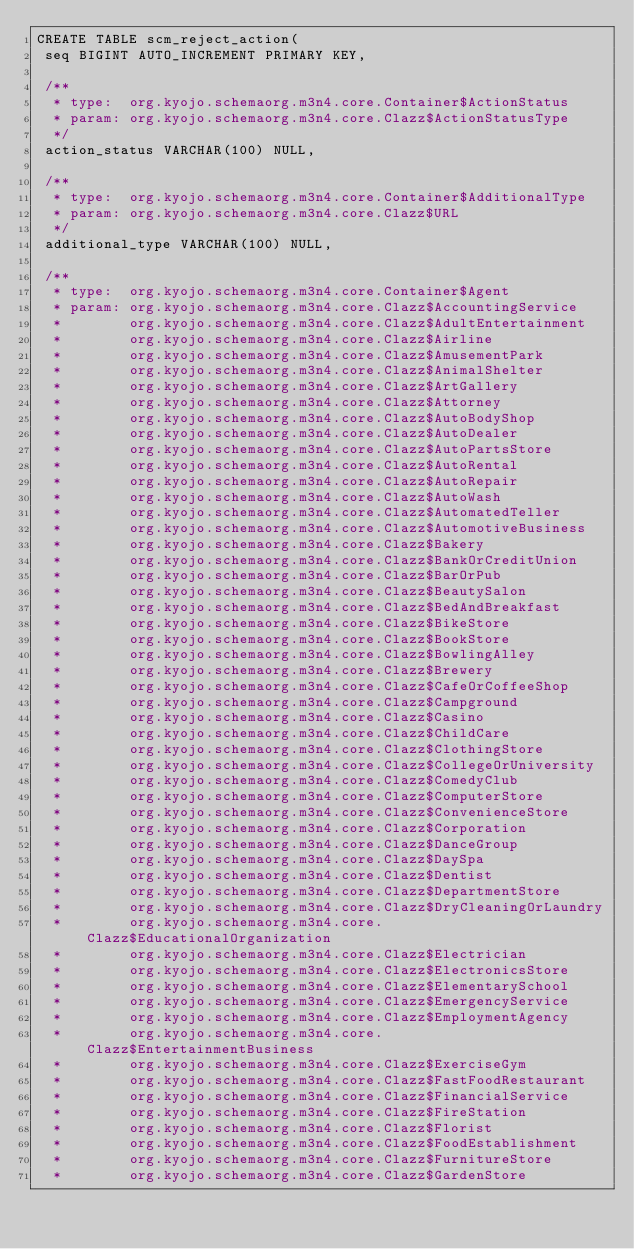Convert code to text. <code><loc_0><loc_0><loc_500><loc_500><_SQL_>CREATE TABLE scm_reject_action(
 seq BIGINT AUTO_INCREMENT PRIMARY KEY,

 /**
  * type:  org.kyojo.schemaorg.m3n4.core.Container$ActionStatus
  * param: org.kyojo.schemaorg.m3n4.core.Clazz$ActionStatusType
  */
 action_status VARCHAR(100) NULL,

 /**
  * type:  org.kyojo.schemaorg.m3n4.core.Container$AdditionalType
  * param: org.kyojo.schemaorg.m3n4.core.Clazz$URL
  */
 additional_type VARCHAR(100) NULL,

 /**
  * type:  org.kyojo.schemaorg.m3n4.core.Container$Agent
  * param: org.kyojo.schemaorg.m3n4.core.Clazz$AccountingService
  *        org.kyojo.schemaorg.m3n4.core.Clazz$AdultEntertainment
  *        org.kyojo.schemaorg.m3n4.core.Clazz$Airline
  *        org.kyojo.schemaorg.m3n4.core.Clazz$AmusementPark
  *        org.kyojo.schemaorg.m3n4.core.Clazz$AnimalShelter
  *        org.kyojo.schemaorg.m3n4.core.Clazz$ArtGallery
  *        org.kyojo.schemaorg.m3n4.core.Clazz$Attorney
  *        org.kyojo.schemaorg.m3n4.core.Clazz$AutoBodyShop
  *        org.kyojo.schemaorg.m3n4.core.Clazz$AutoDealer
  *        org.kyojo.schemaorg.m3n4.core.Clazz$AutoPartsStore
  *        org.kyojo.schemaorg.m3n4.core.Clazz$AutoRental
  *        org.kyojo.schemaorg.m3n4.core.Clazz$AutoRepair
  *        org.kyojo.schemaorg.m3n4.core.Clazz$AutoWash
  *        org.kyojo.schemaorg.m3n4.core.Clazz$AutomatedTeller
  *        org.kyojo.schemaorg.m3n4.core.Clazz$AutomotiveBusiness
  *        org.kyojo.schemaorg.m3n4.core.Clazz$Bakery
  *        org.kyojo.schemaorg.m3n4.core.Clazz$BankOrCreditUnion
  *        org.kyojo.schemaorg.m3n4.core.Clazz$BarOrPub
  *        org.kyojo.schemaorg.m3n4.core.Clazz$BeautySalon
  *        org.kyojo.schemaorg.m3n4.core.Clazz$BedAndBreakfast
  *        org.kyojo.schemaorg.m3n4.core.Clazz$BikeStore
  *        org.kyojo.schemaorg.m3n4.core.Clazz$BookStore
  *        org.kyojo.schemaorg.m3n4.core.Clazz$BowlingAlley
  *        org.kyojo.schemaorg.m3n4.core.Clazz$Brewery
  *        org.kyojo.schemaorg.m3n4.core.Clazz$CafeOrCoffeeShop
  *        org.kyojo.schemaorg.m3n4.core.Clazz$Campground
  *        org.kyojo.schemaorg.m3n4.core.Clazz$Casino
  *        org.kyojo.schemaorg.m3n4.core.Clazz$ChildCare
  *        org.kyojo.schemaorg.m3n4.core.Clazz$ClothingStore
  *        org.kyojo.schemaorg.m3n4.core.Clazz$CollegeOrUniversity
  *        org.kyojo.schemaorg.m3n4.core.Clazz$ComedyClub
  *        org.kyojo.schemaorg.m3n4.core.Clazz$ComputerStore
  *        org.kyojo.schemaorg.m3n4.core.Clazz$ConvenienceStore
  *        org.kyojo.schemaorg.m3n4.core.Clazz$Corporation
  *        org.kyojo.schemaorg.m3n4.core.Clazz$DanceGroup
  *        org.kyojo.schemaorg.m3n4.core.Clazz$DaySpa
  *        org.kyojo.schemaorg.m3n4.core.Clazz$Dentist
  *        org.kyojo.schemaorg.m3n4.core.Clazz$DepartmentStore
  *        org.kyojo.schemaorg.m3n4.core.Clazz$DryCleaningOrLaundry
  *        org.kyojo.schemaorg.m3n4.core.Clazz$EducationalOrganization
  *        org.kyojo.schemaorg.m3n4.core.Clazz$Electrician
  *        org.kyojo.schemaorg.m3n4.core.Clazz$ElectronicsStore
  *        org.kyojo.schemaorg.m3n4.core.Clazz$ElementarySchool
  *        org.kyojo.schemaorg.m3n4.core.Clazz$EmergencyService
  *        org.kyojo.schemaorg.m3n4.core.Clazz$EmploymentAgency
  *        org.kyojo.schemaorg.m3n4.core.Clazz$EntertainmentBusiness
  *        org.kyojo.schemaorg.m3n4.core.Clazz$ExerciseGym
  *        org.kyojo.schemaorg.m3n4.core.Clazz$FastFoodRestaurant
  *        org.kyojo.schemaorg.m3n4.core.Clazz$FinancialService
  *        org.kyojo.schemaorg.m3n4.core.Clazz$FireStation
  *        org.kyojo.schemaorg.m3n4.core.Clazz$Florist
  *        org.kyojo.schemaorg.m3n4.core.Clazz$FoodEstablishment
  *        org.kyojo.schemaorg.m3n4.core.Clazz$FurnitureStore
  *        org.kyojo.schemaorg.m3n4.core.Clazz$GardenStore</code> 